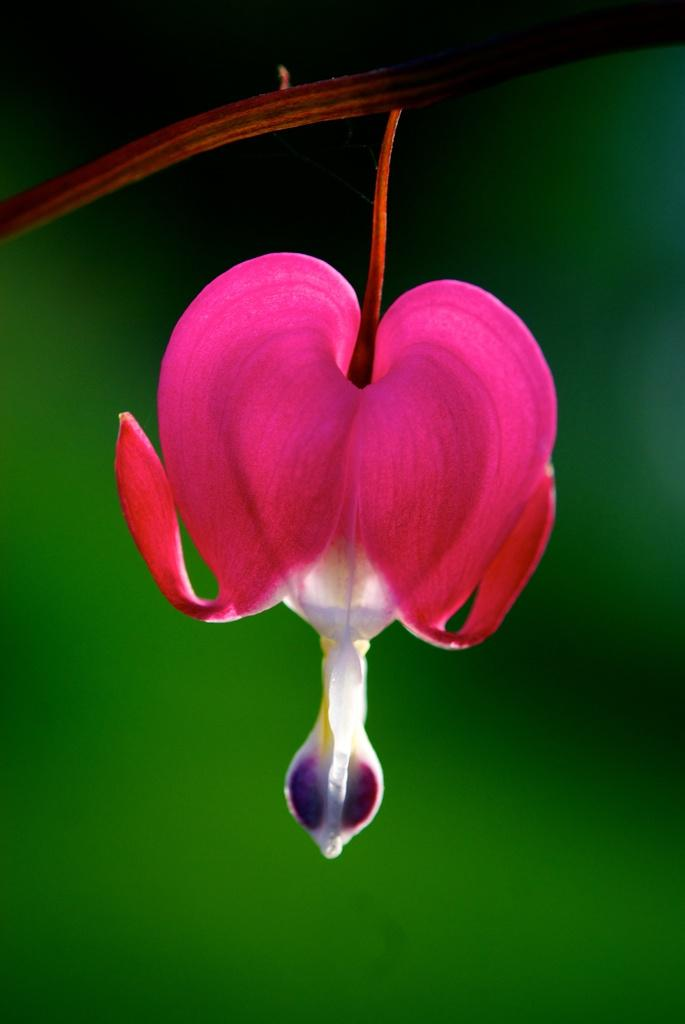What is the main subject of the image? There is a flower in the image. Where is the flower located? The flower is on a branch. What can be observed about the background of the image? The background of the image is blurred. How many zebras can be seen grazing in the background of the image? There are no zebras present in the image; it features a flower on a branch with a blurred background. 